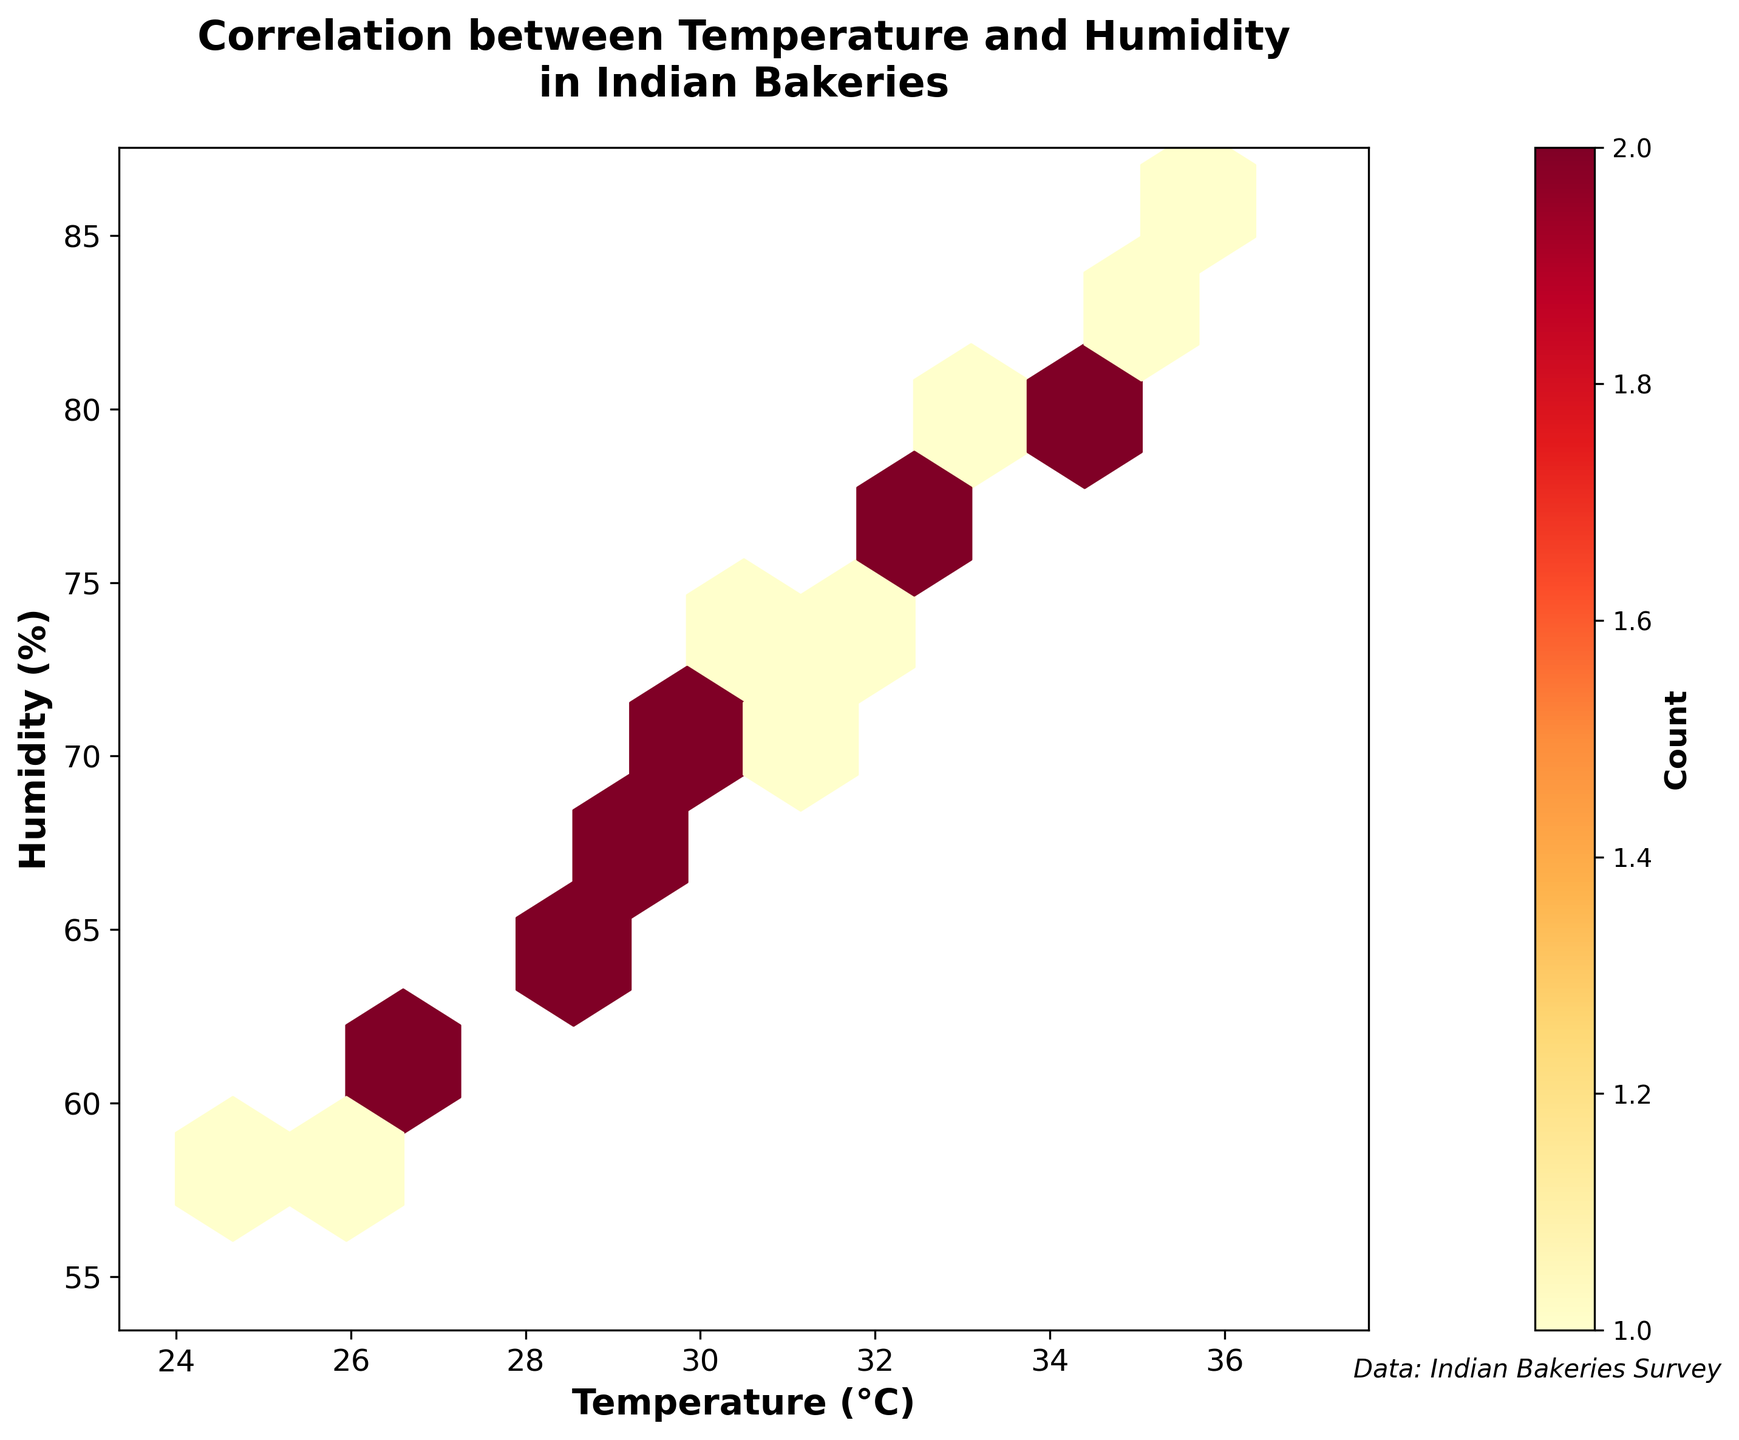What's the title of the figure? The title is usually displayed at the top of the figure. It provides a summary of what the figure is about. In this case, the title is given as: 'Correlation between Temperature and Humidity in Indian Bakeries'.
Answer: Correlation between Temperature and Humidity in Indian Bakeries What do the x-axis and y-axis represent? The x-axis and y-axis labels are present in the figure to indicate what each axis represents. For this plot, the x-axis is labeled 'Temperature (°C)' and the y-axis is labeled 'Humidity (%)'.
Answer: The x-axis represents Temperature (°C) and the y-axis represents Humidity (%) How many points have been plotted with high density on the hexbin plot? In a hexbin plot, areas with higher density of data points are indicated by colors closer to the upper end of the color map. In this case, the color transitions to darker shades of yellow/red. We count the hexagons with these colors to determine high density areas.
Answer: There are multiple hexagons with high density, indicated by dark shades of yellow/red What is the range of the temperature data on the x-axis? The range of the temperature data can be observed from the lowest to the highest values on the x-axis. According to the plot, temperature values extend from around 25°C to 36°C.
Answer: 25°C to 36°C How does the color of hexagons relate to the count of data points? The color of hexagons in a hexbin plot indicates the count of data points within that hexagon. The color map 'YlOrRd' is used here, where lighter colors represent lower counts and darker colors represent higher counts. The legend or color bar helps in understanding this relationship.
Answer: Darker colors represent higher counts and lighter colors represent lower counts What temperature and humidity range seem to have the highest concentration of data points? By identifying the hexagons with the darkest color, one can infer the range of temperature and humidity where there is a high concentration of data. In this plot, the highest concentration appears to be around 28-32°C for temperature and 65-75% for humidity.
Answer: Around 28-32°C for temperature and 65-75% for humidity Compare the number of data points at 25°C and 36°C. Which one has more? By locating the temperature values on the x-axis and observing the color of the hexagons at these positions, we can compare the density. Here, 36°C is associated with darker hexagons compared to 25°C, indicating more data points at 36°C.
Answer: 36°C has more data points What's the average humidity at a temperature of 31°C? We observe the hexagons that lie along the vertical line representing 31°C on the x-axis and estimate their corresponding humidity percentage values. Then we calculate the approximate average.
Answer: Approximately 72% Is there a clear correlation between temperature and humidity levels? By observing the general trend in the hexbin plot, one can understand if an increase in one variable is associated with an increase or decrease in the other. Here, as the temperature increases, humidity also tends to increase, indicating a positive correlation.
Answer: Yes, there is a positive correlation 